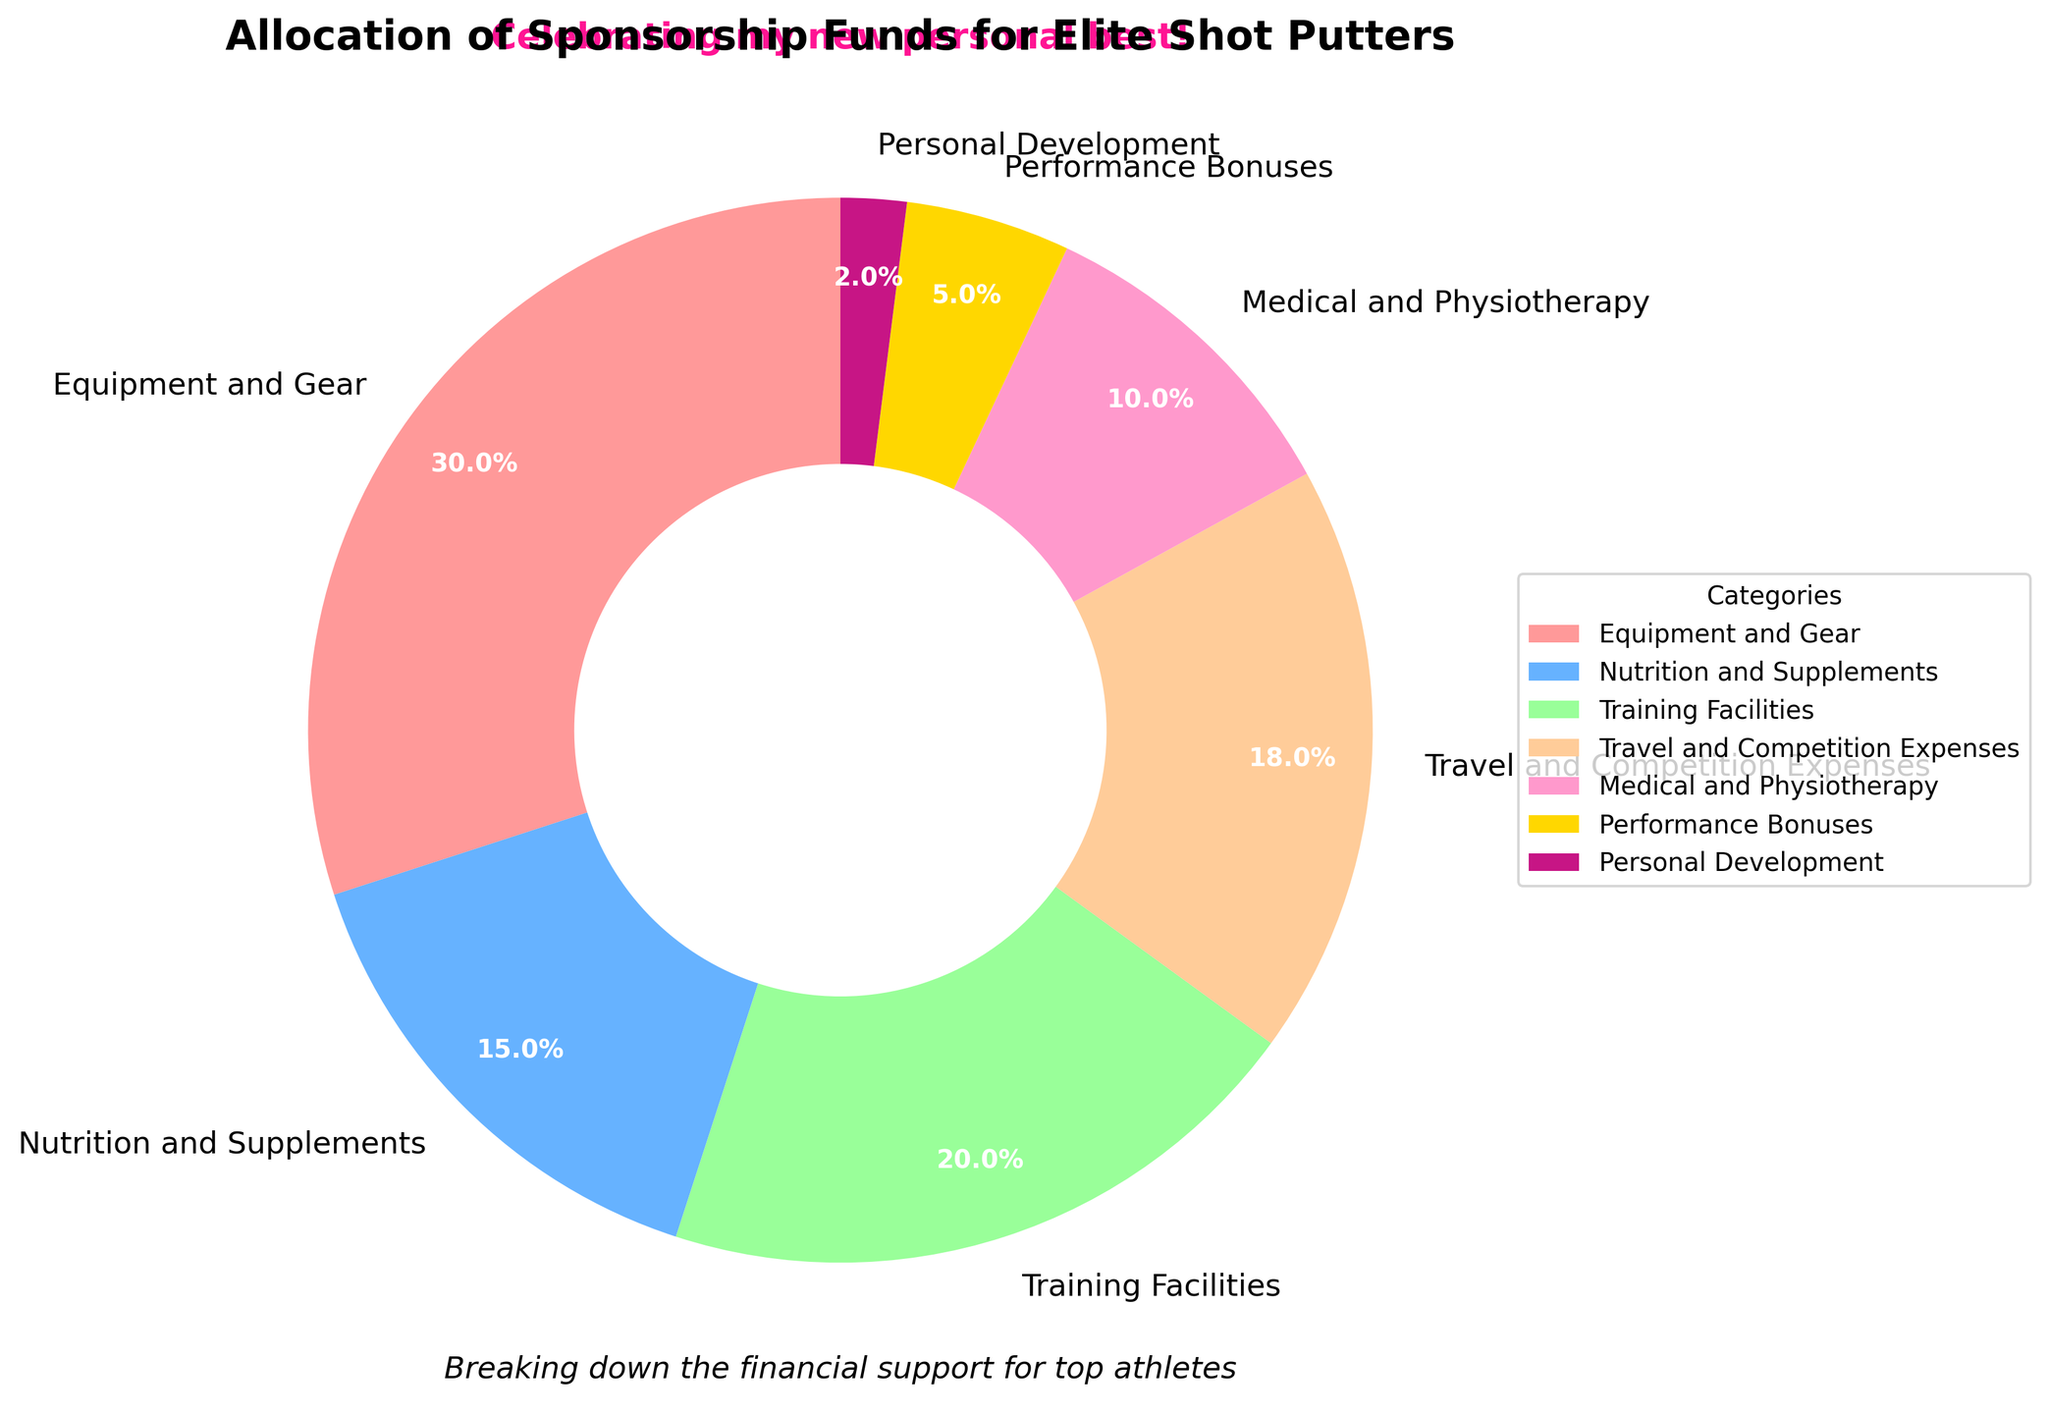Which category receives the largest percentage of sponsorship funds? The Equipment and Gear category accounts for 30% of the sponsorship funds, which is visually represented as the largest wedge in the pie chart.
Answer: Equipment and Gear What is the combined percentage of funds allocated to Travel and Competition Expenses and Medical and Physiotherapy? Travel and Competition Expenses are allocated 18% and Medical and Physiotherapy are 10%. Adding these together gives 18% + 10% = 28%.
Answer: 28% How much more percentage funding is given to Training Facilities compared to Performance Bonuses? Training Facilities receive 20%, and Performance Bonuses receive 5%. The difference between them is 20% - 5% = 15%.
Answer: 15% Which category gets the least amount of sponsorship funds? Personal Development receives the least amount of sponsorship funds at 2%, which is shown as the smallest wedge in the pie chart.
Answer: Personal Development What is the sum of the percentages allocated to categories other than Equipment and Gear? The total percentage is 100%. Removing the Equipment and Gear's 30%, we get 100% - 30% = 70%.
Answer: 70% How does the percentage for Travel and Competition Expenses compare to Nutrition and Supplements? Travel and Competition Expenses receive 18% and Nutrition and Supplements receive 15%. So, Travel and Competition Expenses receive a larger percentage by 3%.
Answer: 3% Which category is represented by the red color in the pie chart? The color scheme indicates that Equipment and Gear is shown in red, as it is the largest segment of 30%.
Answer: Equipment and Gear If the budget for Nutrition and Supplements were doubled, what would the new percentage allocation be? The original allocation for Nutrition and Supplements is 15%. Doubling this would result in 15% * 2 = 30%.
Answer: 30% 